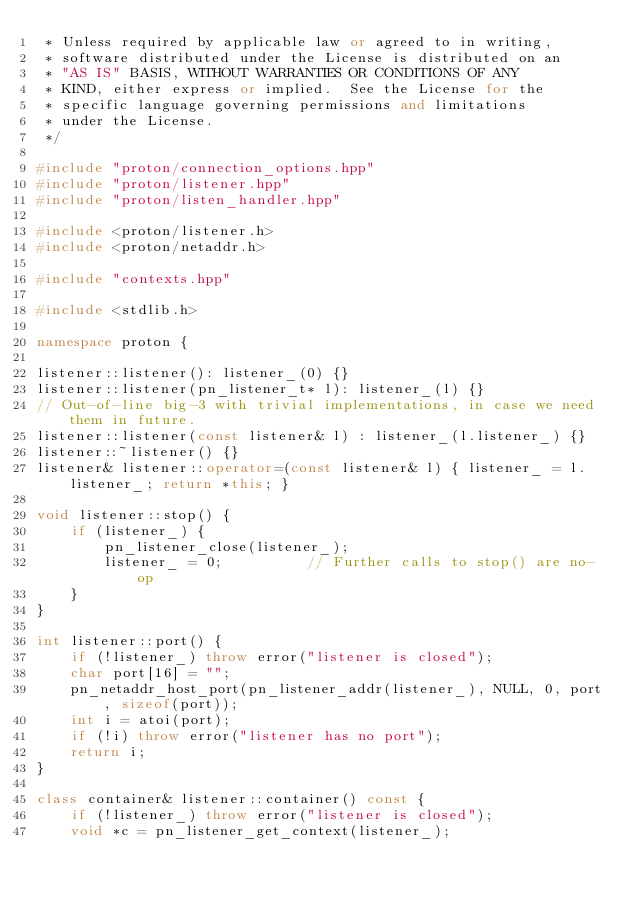<code> <loc_0><loc_0><loc_500><loc_500><_C++_> * Unless required by applicable law or agreed to in writing,
 * software distributed under the License is distributed on an
 * "AS IS" BASIS, WITHOUT WARRANTIES OR CONDITIONS OF ANY
 * KIND, either express or implied.  See the License for the
 * specific language governing permissions and limitations
 * under the License.
 */

#include "proton/connection_options.hpp"
#include "proton/listener.hpp"
#include "proton/listen_handler.hpp"

#include <proton/listener.h>
#include <proton/netaddr.h>

#include "contexts.hpp"

#include <stdlib.h>

namespace proton {

listener::listener(): listener_(0) {}
listener::listener(pn_listener_t* l): listener_(l) {}
// Out-of-line big-3 with trivial implementations, in case we need them in future. 
listener::listener(const listener& l) : listener_(l.listener_) {}
listener::~listener() {}
listener& listener::operator=(const listener& l) { listener_ = l.listener_; return *this; }

void listener::stop() {
    if (listener_) {
        pn_listener_close(listener_);
        listener_ = 0;          // Further calls to stop() are no-op
    }
}

int listener::port() {
    if (!listener_) throw error("listener is closed");
    char port[16] = "";
    pn_netaddr_host_port(pn_listener_addr(listener_), NULL, 0, port, sizeof(port));
    int i = atoi(port);
    if (!i) throw error("listener has no port");
    return i;
}

class container& listener::container() const {
    if (!listener_) throw error("listener is closed");
    void *c = pn_listener_get_context(listener_);</code> 